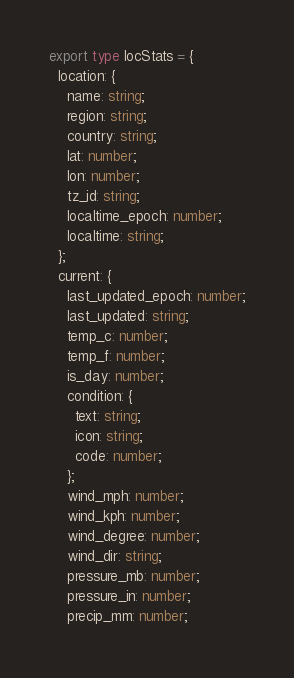Convert code to text. <code><loc_0><loc_0><loc_500><loc_500><_TypeScript_>export type locStats = {
  location: {
    name: string;
    region: string;
    country: string;
    lat: number;
    lon: number;
    tz_id: string;
    localtime_epoch: number;
    localtime: string;
  };
  current: {
    last_updated_epoch: number;
    last_updated: string;
    temp_c: number;
    temp_f: number;
    is_day: number;
    condition: {
      text: string;
      icon: string;
      code: number;
    };
    wind_mph: number;
    wind_kph: number;
    wind_degree: number;
    wind_dir: string;
    pressure_mb: number;
    pressure_in: number;
    precip_mm: number;</code> 